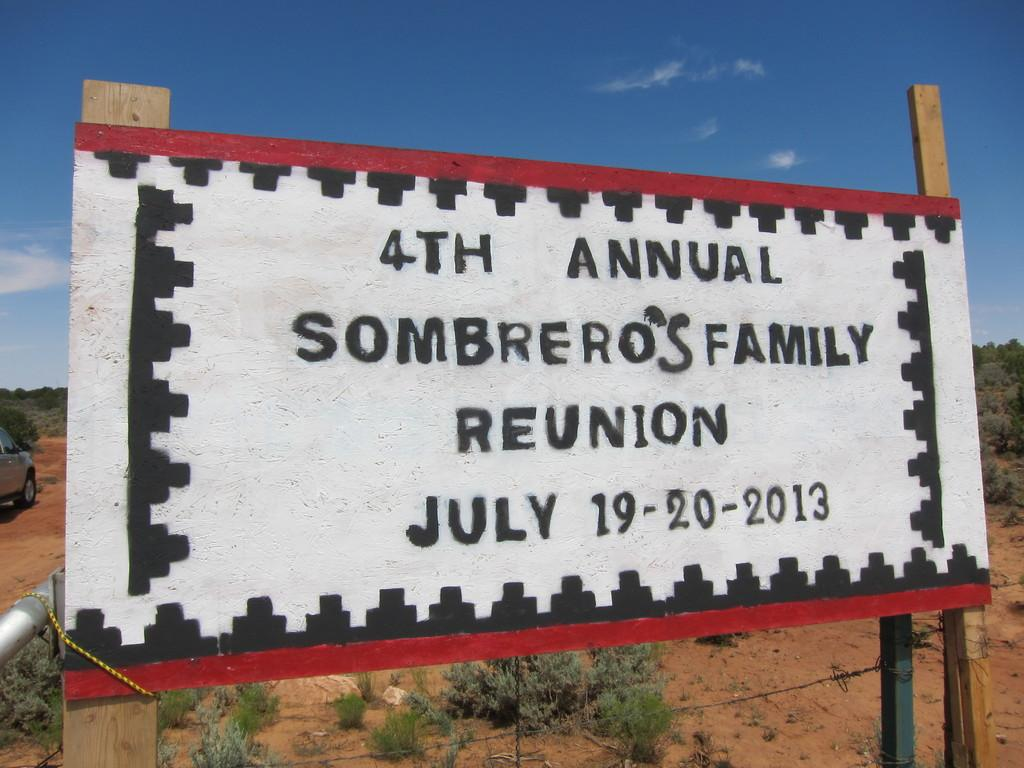<image>
Create a compact narrative representing the image presented. A sign advertises an event taking place on July 19th and 20th in 2013. 